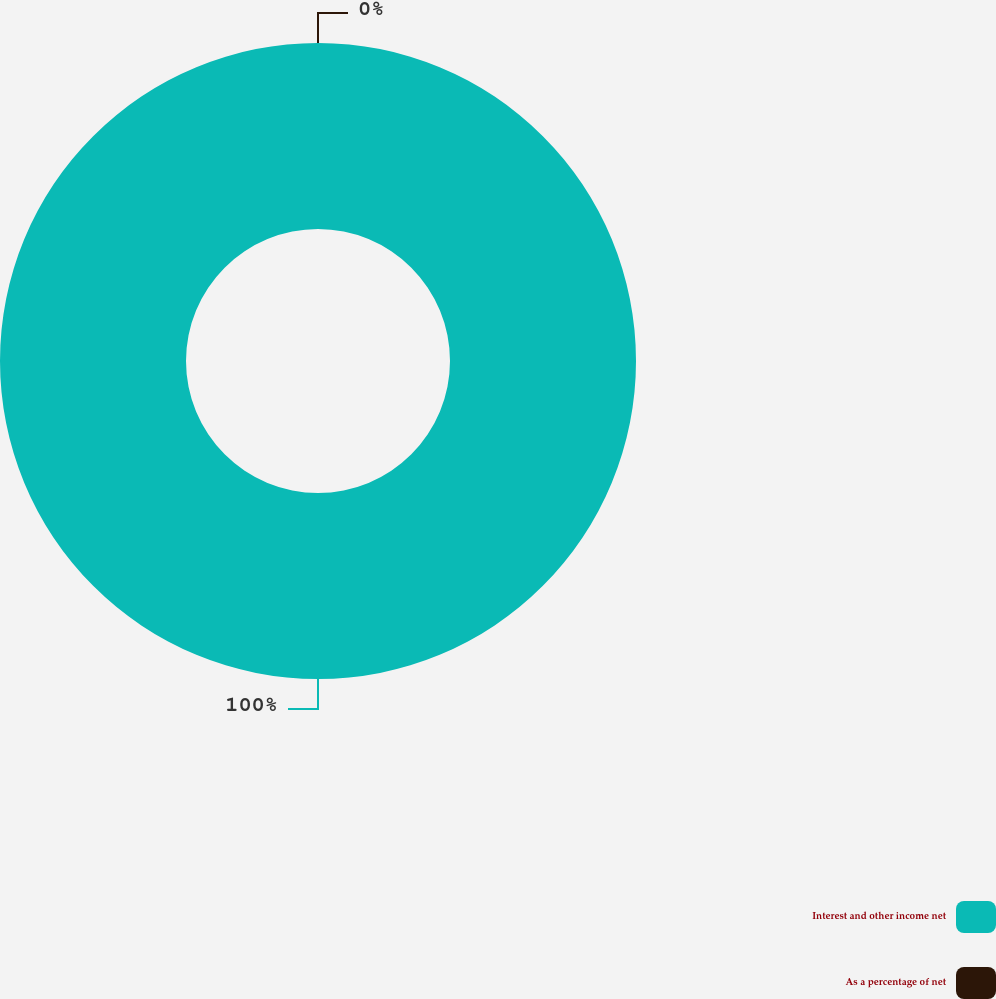Convert chart to OTSL. <chart><loc_0><loc_0><loc_500><loc_500><pie_chart><fcel>Interest and other income net<fcel>As a percentage of net<nl><fcel>100.0%<fcel>0.0%<nl></chart> 